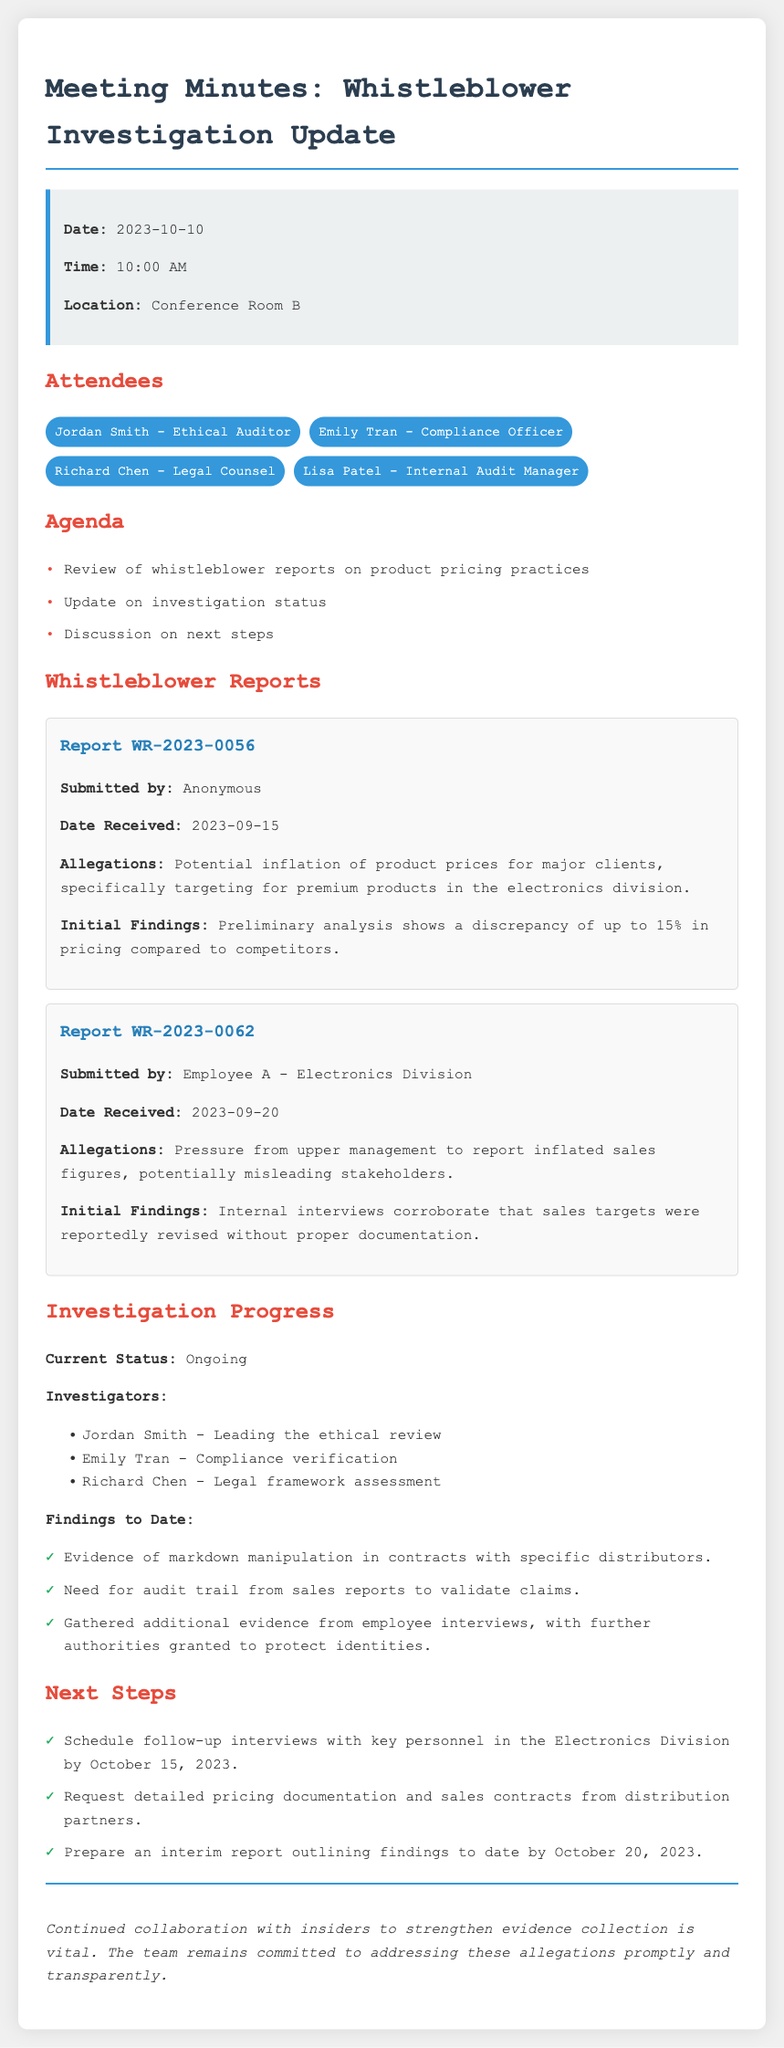What is the date of the meeting? The meeting date is specified in the info box at the beginning of the document.
Answer: 2023-10-10 Who submitted Report WR-2023-0062? The name of the individual who submitted this report is mentioned in the report section under the allegations.
Answer: Employee A - Electronics Division What was the initial finding of Report WR-2023-0056? The document includes specific details about initial findings for each report.
Answer: Discrepancy of up to 15% in pricing compared to competitors Who leads the ethical review in the investigation team? The role of leading the ethical review is assigned to a specific attendee mentioned in the investigation progress section.
Answer: Jordan Smith What needs to be validated according to the findings? The findings section refers to a specific aspect that requires further verification as part of the investigation.
Answer: Audit trail from sales reports What is the current status of the investigation? The status of the investigation is stated clearly in the document under the investigation progress section.
Answer: Ongoing When is the deadline for the interim report? The deadline for preparing the interim report is mentioned in the next steps section of the document.
Answer: October 20, 2023 What is emphasized as vital for the investigation process? The conclusion section indicates what is essential for strengthening the investigation's credibility and evidence collection.
Answer: Collaboration with insiders 